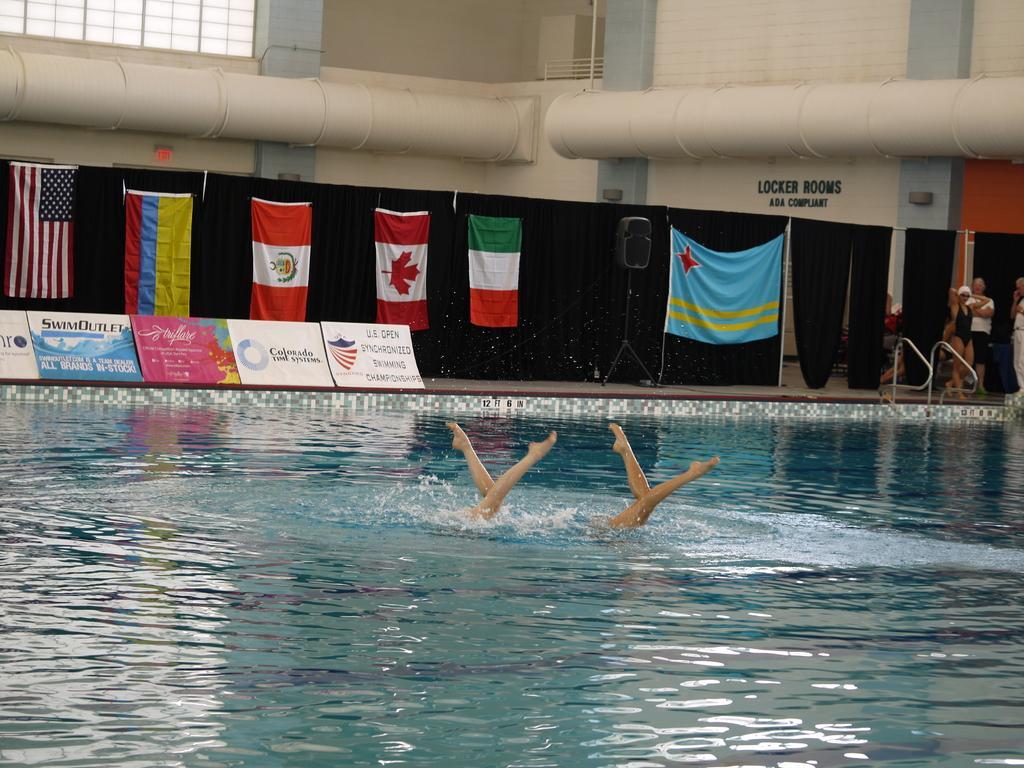Describe this image in one or two sentences. In this picture we can see two people in the water and we can see the only person's legs. Behind the people there are boards, flags a speaker on the stand and some people are standing. Behind the flags there are black curtains and a wall with pipes. 